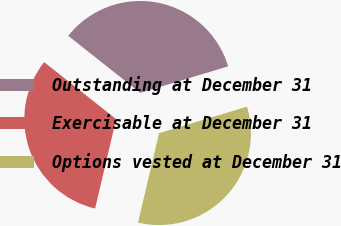Convert chart to OTSL. <chart><loc_0><loc_0><loc_500><loc_500><pie_chart><fcel>Outstanding at December 31<fcel>Exercisable at December 31<fcel>Options vested at December 31<nl><fcel>34.68%<fcel>31.98%<fcel>33.33%<nl></chart> 